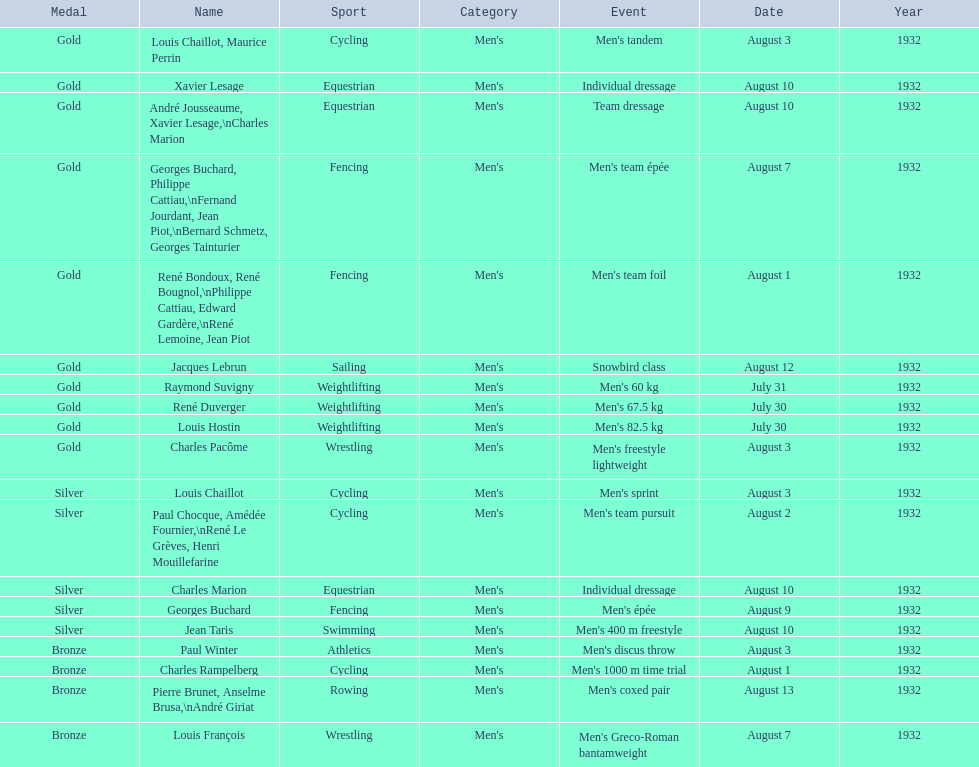Louis chaillot won a gold medal for cycling and a silver medal for what sport? Cycling. 